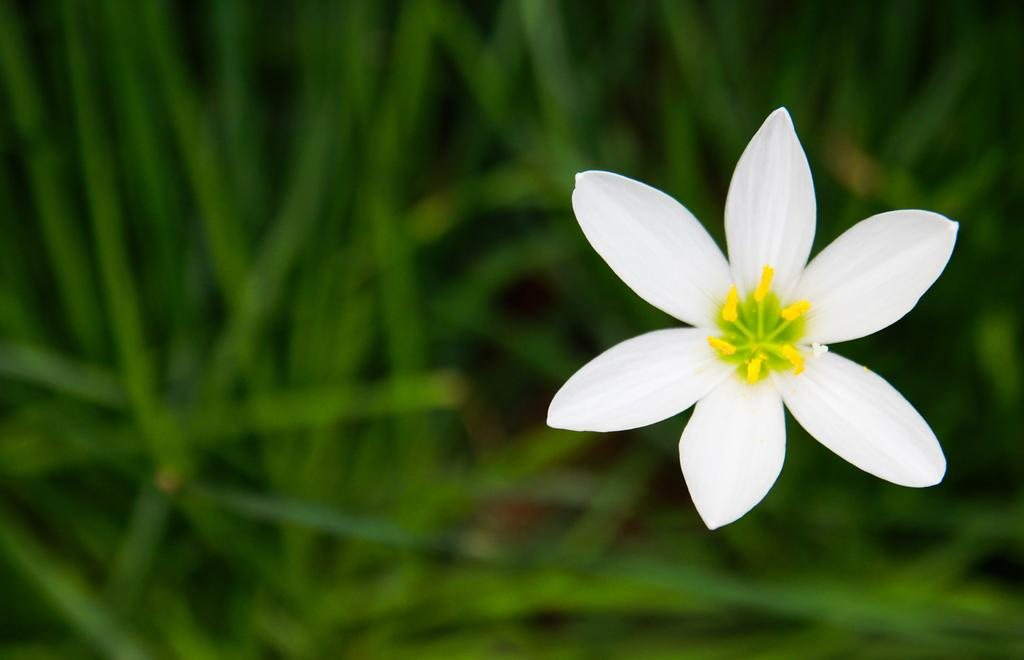What is the main subject of the image? There is a flower in the image. What is the color of the flower? The flower is white in color. Are there any other colors visible on the flower? Yes, there are yellow color buds on the flower. What can be seen in the background of the image? There is greenery in the background of the image. What type of receipt can be seen in the image? There is no receipt present in the image; it features a white flower with yellow buds and a background of greenery. 